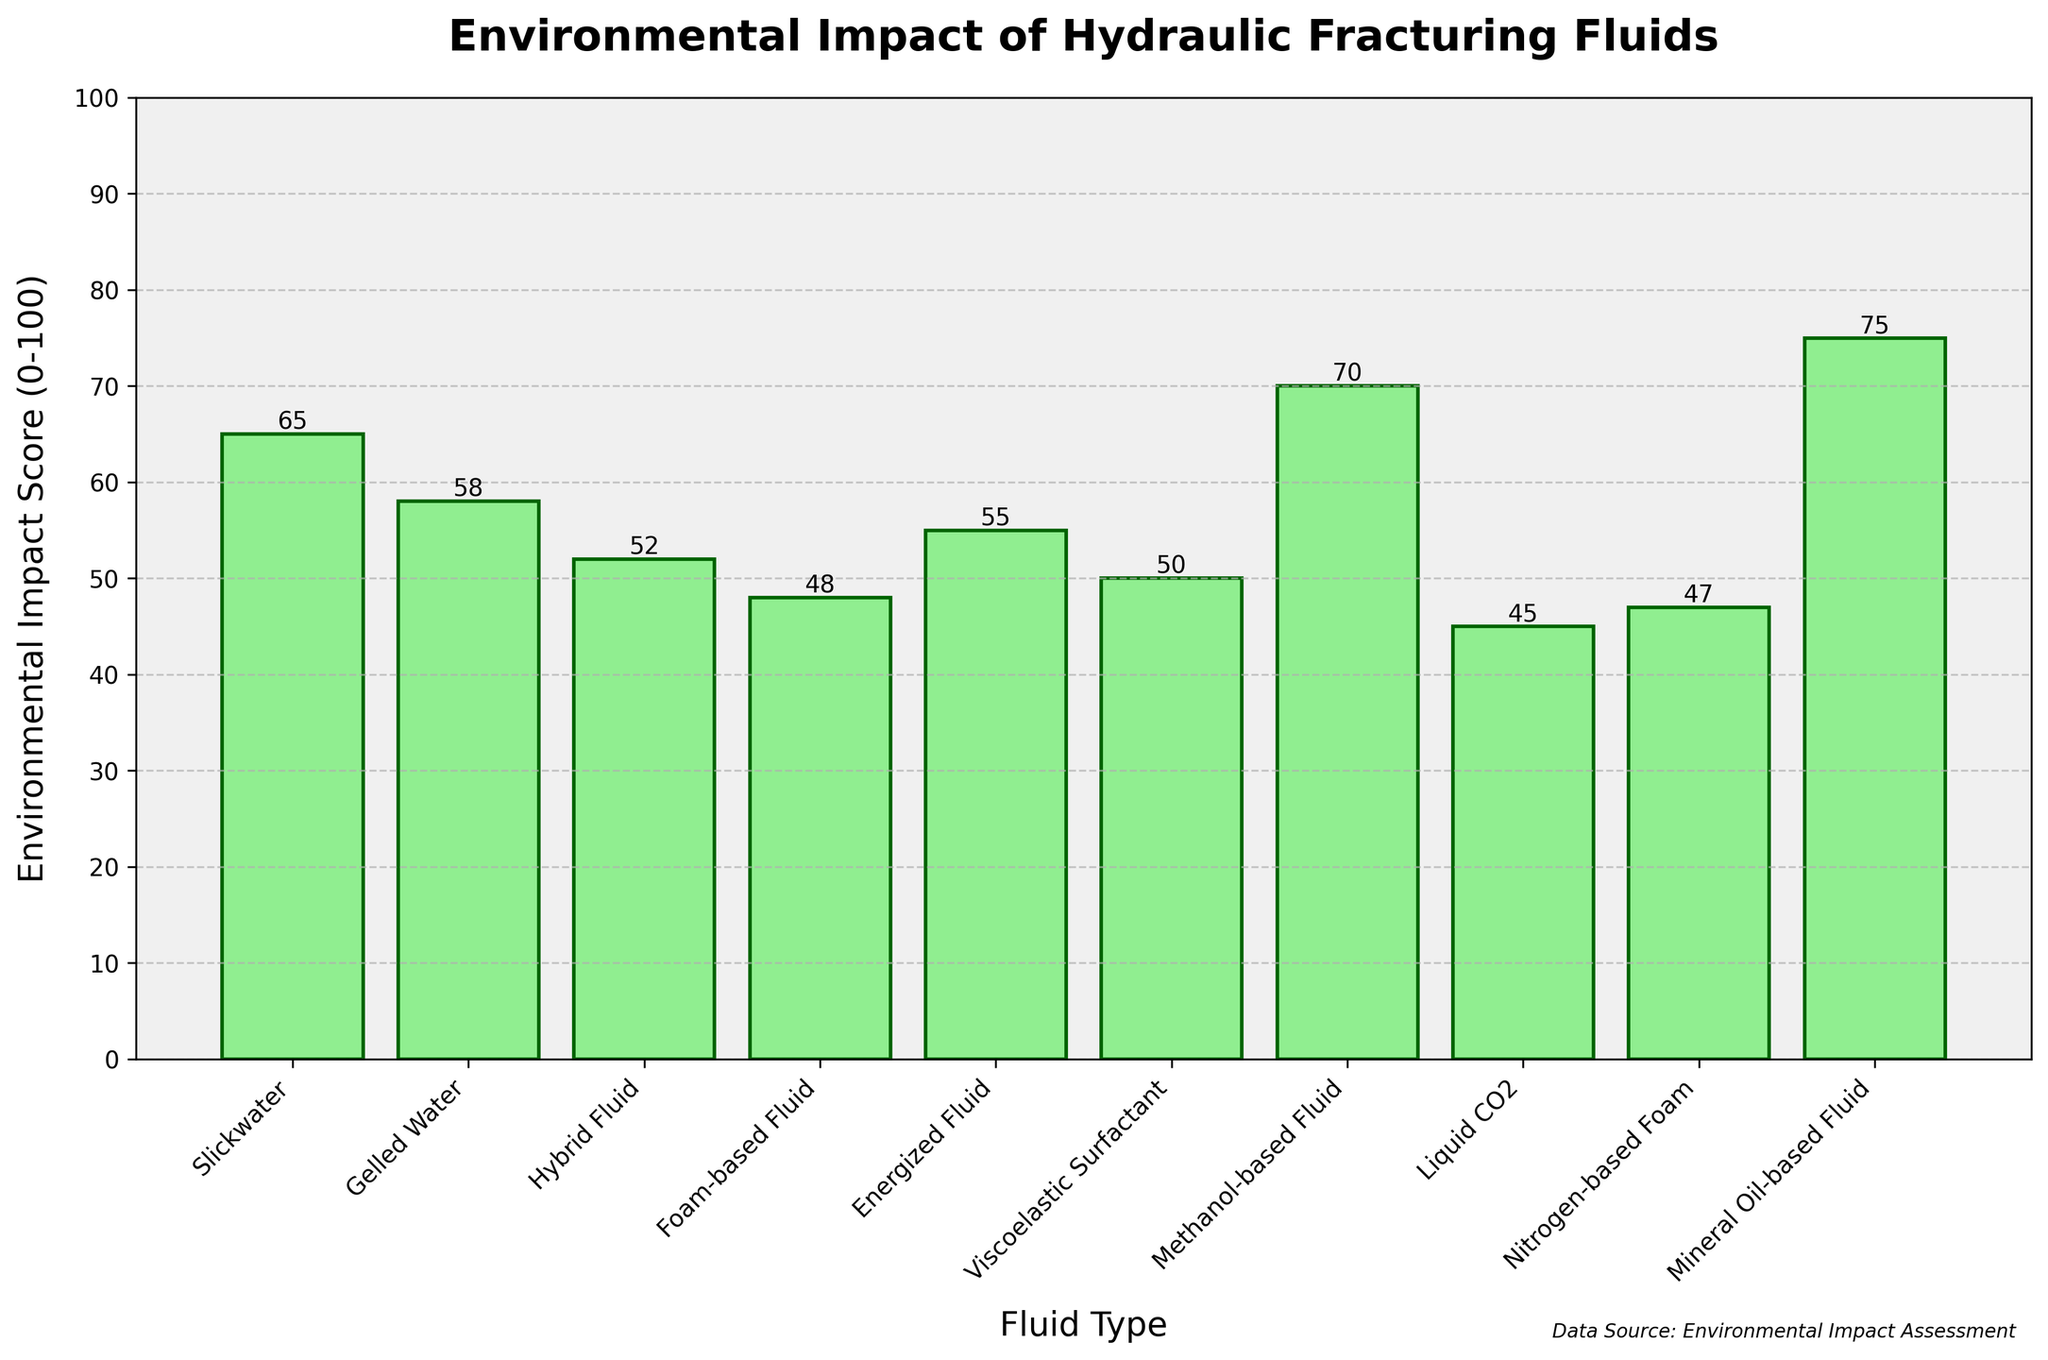what is the fluid with the highest environmental impact score? Look for the bar with the highest height in the chart. The highest bar corresponds to the "Mineral Oil-based Fluid" with an impact score of 75.
Answer: Mineral Oil-based Fluid which fluid type has the lowest environmental impact score? Identify the shortest bar in the chart. The shortest bar belongs to "Liquid CO2" with an impact score of 45.
Answer: Liquid CO2 compare the environmental impact scores of Slickwater and Gelled Water. Which is higher, and by how much? Compare the heights of the bars for Slickwater and Gelled Water. Slickwater has a score of 65, while Gelled Water has a score of 58. The difference is 65 - 58 = 7.
Answer: Slickwater by 7 what is the average environmental impact score of the fluids listed? Add up all the impact scores and divide by the number of fluids. The scores are (65 + 58 + 52 + 48 + 55 + 50 + 70 + 45 + 47 + 75) = 565. There are 10 fluids, so the average is 565 / 10 = 56.5.
Answer: 56.5 which fluid type comes third when ordered by environmental impact score from highest to lowest? Order the fluids by their impact scores: 75, 70, 65, 58, 55, 52, 50, 48, 47, 45. The third highest is Slickwater with a score of 65.
Answer: Slickwater if you sum the environmental impact scores of Foam-based Fluid and Methanol-based Fluid, what do you get? Identify the impact scores: Foam-based Fluid has 48, and Methanol-based Fluid has 70. The sum is 48 + 70 = 118.
Answer: 118 how many fluids have an environmental impact score greater than 50? Count the number of bars with a height greater than the 50 mark on the y-axis. These are Slickwater (65), Gelled Water (58), Hybrid Fluid (52), Energized Fluid (55), Methanol-based Fluid (70), and Mineral Oil-based Fluid (75). There are 6 such bars.
Answer: 6 